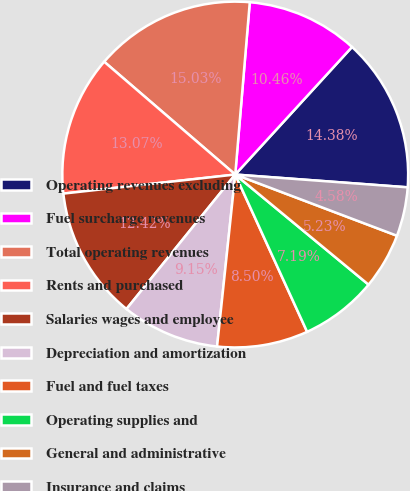<chart> <loc_0><loc_0><loc_500><loc_500><pie_chart><fcel>Operating revenues excluding<fcel>Fuel surcharge revenues<fcel>Total operating revenues<fcel>Rents and purchased<fcel>Salaries wages and employee<fcel>Depreciation and amortization<fcel>Fuel and fuel taxes<fcel>Operating supplies and<fcel>General and administrative<fcel>Insurance and claims<nl><fcel>14.38%<fcel>10.46%<fcel>15.03%<fcel>13.07%<fcel>12.42%<fcel>9.15%<fcel>8.5%<fcel>7.19%<fcel>5.23%<fcel>4.58%<nl></chart> 